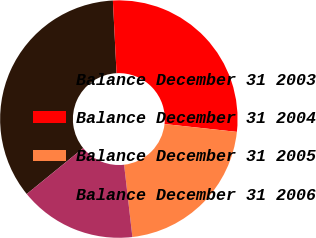Convert chart. <chart><loc_0><loc_0><loc_500><loc_500><pie_chart><fcel>Balance December 31 2003<fcel>Balance December 31 2004<fcel>Balance December 31 2005<fcel>Balance December 31 2006<nl><fcel>35.07%<fcel>27.52%<fcel>21.46%<fcel>15.95%<nl></chart> 